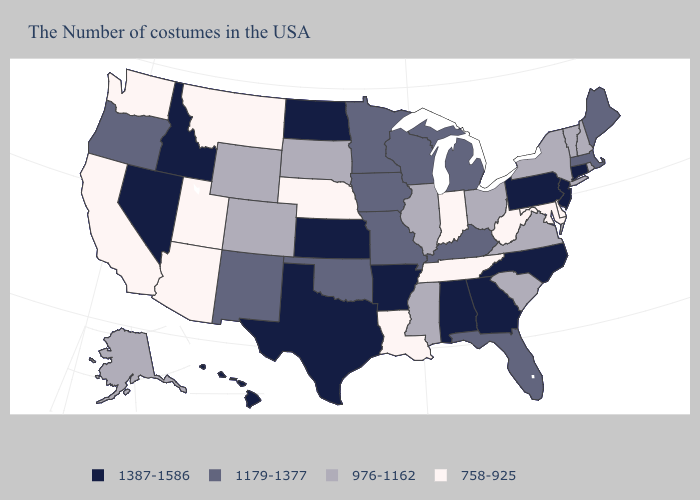Does Oklahoma have the lowest value in the USA?
Answer briefly. No. Does Utah have the highest value in the West?
Short answer required. No. Does Montana have the lowest value in the USA?
Keep it brief. Yes. Among the states that border Kentucky , which have the highest value?
Concise answer only. Missouri. Which states hav the highest value in the Northeast?
Keep it brief. Connecticut, New Jersey, Pennsylvania. Among the states that border South Dakota , which have the lowest value?
Be succinct. Nebraska, Montana. How many symbols are there in the legend?
Be succinct. 4. What is the lowest value in the USA?
Keep it brief. 758-925. Among the states that border Vermont , which have the highest value?
Answer briefly. Massachusetts. What is the value of Arizona?
Keep it brief. 758-925. Name the states that have a value in the range 758-925?
Be succinct. Delaware, Maryland, West Virginia, Indiana, Tennessee, Louisiana, Nebraska, Utah, Montana, Arizona, California, Washington. What is the value of New Mexico?
Answer briefly. 1179-1377. Does South Carolina have a lower value than Oregon?
Quick response, please. Yes. Name the states that have a value in the range 758-925?
Answer briefly. Delaware, Maryland, West Virginia, Indiana, Tennessee, Louisiana, Nebraska, Utah, Montana, Arizona, California, Washington. 